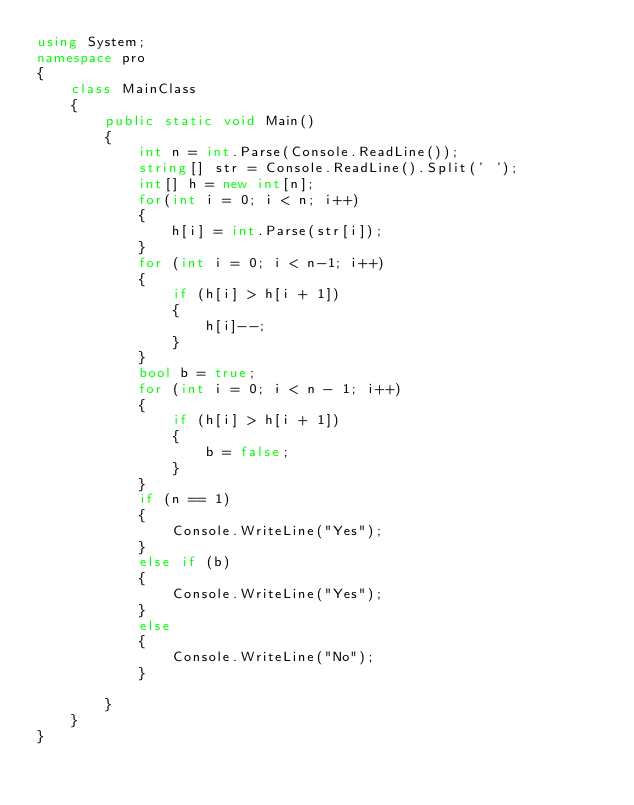Convert code to text. <code><loc_0><loc_0><loc_500><loc_500><_C#_>using System;
namespace pro
{
    class MainClass
    {
        public static void Main()
        {
            int n = int.Parse(Console.ReadLine());
            string[] str = Console.ReadLine().Split(' ');
            int[] h = new int[n];
            for(int i = 0; i < n; i++)
            {
                h[i] = int.Parse(str[i]);
            }
            for (int i = 0; i < n-1; i++)
            {
                if (h[i] > h[i + 1])
                {
                    h[i]--;
                }
            }
            bool b = true;
            for (int i = 0; i < n - 1; i++)
            {
                if (h[i] > h[i + 1])
                {
                    b = false;
                }
            }
            if (n == 1)
            {
                Console.WriteLine("Yes");
            }
            else if (b)
            {
                Console.WriteLine("Yes");
            }
            else
            {
                Console.WriteLine("No");
            }

        }
    }
}</code> 